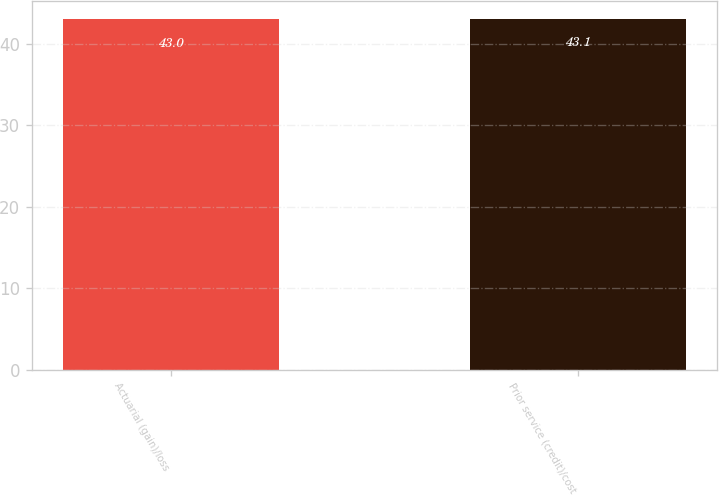<chart> <loc_0><loc_0><loc_500><loc_500><bar_chart><fcel>Actuarial (gain)/loss<fcel>Prior service (credit)/cost<nl><fcel>43<fcel>43.1<nl></chart> 